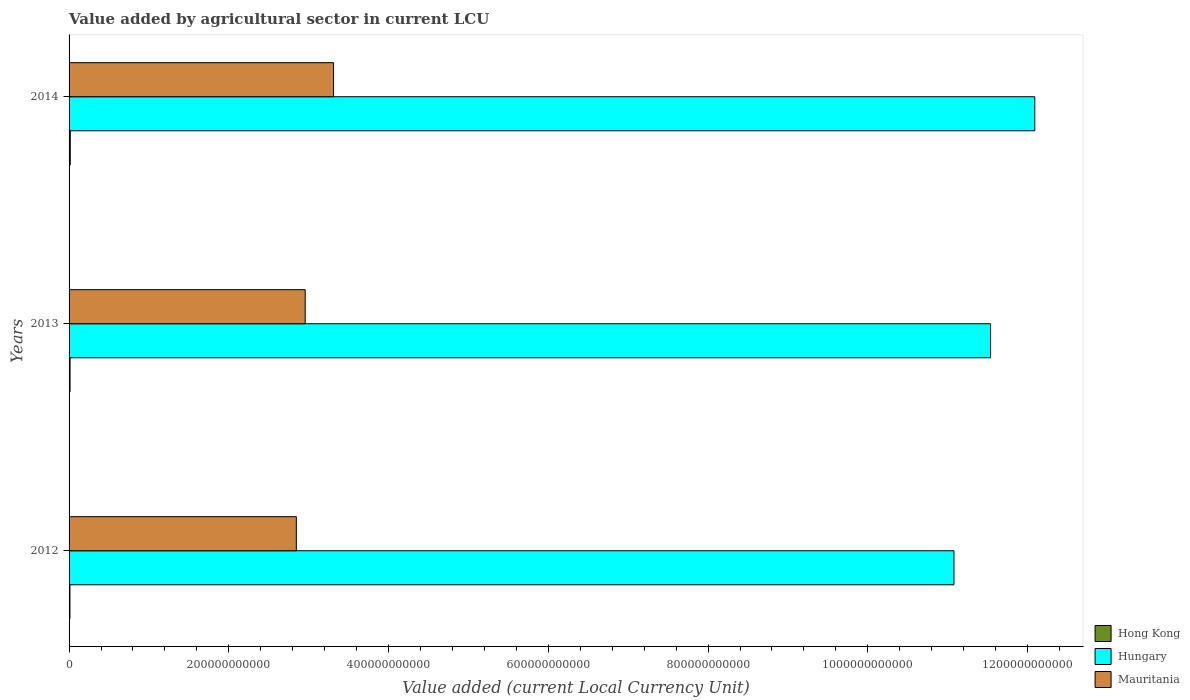How many different coloured bars are there?
Offer a terse response. 3. How many groups of bars are there?
Offer a very short reply. 3. Are the number of bars on each tick of the Y-axis equal?
Your response must be concise. Yes. How many bars are there on the 3rd tick from the top?
Make the answer very short. 3. What is the value added by agricultural sector in Mauritania in 2014?
Give a very brief answer. 3.31e+11. Across all years, what is the maximum value added by agricultural sector in Mauritania?
Provide a succinct answer. 3.31e+11. Across all years, what is the minimum value added by agricultural sector in Hungary?
Offer a very short reply. 1.11e+12. In which year was the value added by agricultural sector in Hungary maximum?
Provide a short and direct response. 2014. What is the total value added by agricultural sector in Mauritania in the graph?
Offer a terse response. 9.11e+11. What is the difference between the value added by agricultural sector in Hong Kong in 2012 and that in 2014?
Keep it short and to the point. -3.82e+08. What is the difference between the value added by agricultural sector in Hong Kong in 2013 and the value added by agricultural sector in Hungary in 2012?
Provide a succinct answer. -1.11e+12. What is the average value added by agricultural sector in Hong Kong per year?
Offer a very short reply. 1.28e+09. In the year 2012, what is the difference between the value added by agricultural sector in Mauritania and value added by agricultural sector in Hungary?
Your answer should be very brief. -8.23e+11. In how many years, is the value added by agricultural sector in Hong Kong greater than 720000000000 LCU?
Ensure brevity in your answer.  0. What is the ratio of the value added by agricultural sector in Hong Kong in 2012 to that in 2013?
Your response must be concise. 0.91. Is the value added by agricultural sector in Hong Kong in 2013 less than that in 2014?
Your answer should be very brief. Yes. Is the difference between the value added by agricultural sector in Mauritania in 2012 and 2014 greater than the difference between the value added by agricultural sector in Hungary in 2012 and 2014?
Provide a short and direct response. Yes. What is the difference between the highest and the second highest value added by agricultural sector in Mauritania?
Your response must be concise. 3.55e+1. What is the difference between the highest and the lowest value added by agricultural sector in Hong Kong?
Your answer should be compact. 3.82e+08. Is the sum of the value added by agricultural sector in Hungary in 2012 and 2013 greater than the maximum value added by agricultural sector in Mauritania across all years?
Keep it short and to the point. Yes. What does the 3rd bar from the top in 2013 represents?
Make the answer very short. Hong Kong. What does the 3rd bar from the bottom in 2013 represents?
Your answer should be very brief. Mauritania. Is it the case that in every year, the sum of the value added by agricultural sector in Hong Kong and value added by agricultural sector in Hungary is greater than the value added by agricultural sector in Mauritania?
Provide a succinct answer. Yes. Are all the bars in the graph horizontal?
Ensure brevity in your answer.  Yes. What is the difference between two consecutive major ticks on the X-axis?
Provide a short and direct response. 2.00e+11. Does the graph contain grids?
Ensure brevity in your answer.  No. How many legend labels are there?
Ensure brevity in your answer.  3. What is the title of the graph?
Keep it short and to the point. Value added by agricultural sector in current LCU. What is the label or title of the X-axis?
Keep it short and to the point. Value added (current Local Currency Unit). What is the Value added (current Local Currency Unit) in Hong Kong in 2012?
Your answer should be very brief. 1.11e+09. What is the Value added (current Local Currency Unit) in Hungary in 2012?
Provide a succinct answer. 1.11e+12. What is the Value added (current Local Currency Unit) in Mauritania in 2012?
Offer a very short reply. 2.85e+11. What is the Value added (current Local Currency Unit) of Hong Kong in 2013?
Your answer should be very brief. 1.22e+09. What is the Value added (current Local Currency Unit) in Hungary in 2013?
Provide a succinct answer. 1.15e+12. What is the Value added (current Local Currency Unit) of Mauritania in 2013?
Your answer should be very brief. 2.96e+11. What is the Value added (current Local Currency Unit) of Hong Kong in 2014?
Offer a terse response. 1.50e+09. What is the Value added (current Local Currency Unit) of Hungary in 2014?
Offer a terse response. 1.21e+12. What is the Value added (current Local Currency Unit) of Mauritania in 2014?
Your response must be concise. 3.31e+11. Across all years, what is the maximum Value added (current Local Currency Unit) in Hong Kong?
Your response must be concise. 1.50e+09. Across all years, what is the maximum Value added (current Local Currency Unit) of Hungary?
Your answer should be compact. 1.21e+12. Across all years, what is the maximum Value added (current Local Currency Unit) of Mauritania?
Make the answer very short. 3.31e+11. Across all years, what is the minimum Value added (current Local Currency Unit) in Hong Kong?
Your answer should be very brief. 1.11e+09. Across all years, what is the minimum Value added (current Local Currency Unit) of Hungary?
Provide a succinct answer. 1.11e+12. Across all years, what is the minimum Value added (current Local Currency Unit) of Mauritania?
Offer a very short reply. 2.85e+11. What is the total Value added (current Local Currency Unit) of Hong Kong in the graph?
Your answer should be very brief. 3.84e+09. What is the total Value added (current Local Currency Unit) of Hungary in the graph?
Make the answer very short. 3.47e+12. What is the total Value added (current Local Currency Unit) in Mauritania in the graph?
Keep it short and to the point. 9.11e+11. What is the difference between the Value added (current Local Currency Unit) in Hong Kong in 2012 and that in 2013?
Ensure brevity in your answer.  -1.11e+08. What is the difference between the Value added (current Local Currency Unit) in Hungary in 2012 and that in 2013?
Ensure brevity in your answer.  -4.59e+1. What is the difference between the Value added (current Local Currency Unit) in Mauritania in 2012 and that in 2013?
Provide a succinct answer. -1.11e+1. What is the difference between the Value added (current Local Currency Unit) of Hong Kong in 2012 and that in 2014?
Provide a short and direct response. -3.82e+08. What is the difference between the Value added (current Local Currency Unit) in Hungary in 2012 and that in 2014?
Make the answer very short. -1.01e+11. What is the difference between the Value added (current Local Currency Unit) of Mauritania in 2012 and that in 2014?
Give a very brief answer. -4.66e+1. What is the difference between the Value added (current Local Currency Unit) in Hong Kong in 2013 and that in 2014?
Ensure brevity in your answer.  -2.71e+08. What is the difference between the Value added (current Local Currency Unit) in Hungary in 2013 and that in 2014?
Your answer should be compact. -5.53e+1. What is the difference between the Value added (current Local Currency Unit) of Mauritania in 2013 and that in 2014?
Provide a short and direct response. -3.55e+1. What is the difference between the Value added (current Local Currency Unit) of Hong Kong in 2012 and the Value added (current Local Currency Unit) of Hungary in 2013?
Your answer should be compact. -1.15e+12. What is the difference between the Value added (current Local Currency Unit) of Hong Kong in 2012 and the Value added (current Local Currency Unit) of Mauritania in 2013?
Offer a terse response. -2.95e+11. What is the difference between the Value added (current Local Currency Unit) in Hungary in 2012 and the Value added (current Local Currency Unit) in Mauritania in 2013?
Provide a short and direct response. 8.12e+11. What is the difference between the Value added (current Local Currency Unit) of Hong Kong in 2012 and the Value added (current Local Currency Unit) of Hungary in 2014?
Make the answer very short. -1.21e+12. What is the difference between the Value added (current Local Currency Unit) in Hong Kong in 2012 and the Value added (current Local Currency Unit) in Mauritania in 2014?
Offer a terse response. -3.30e+11. What is the difference between the Value added (current Local Currency Unit) of Hungary in 2012 and the Value added (current Local Currency Unit) of Mauritania in 2014?
Offer a terse response. 7.77e+11. What is the difference between the Value added (current Local Currency Unit) of Hong Kong in 2013 and the Value added (current Local Currency Unit) of Hungary in 2014?
Make the answer very short. -1.21e+12. What is the difference between the Value added (current Local Currency Unit) of Hong Kong in 2013 and the Value added (current Local Currency Unit) of Mauritania in 2014?
Your answer should be compact. -3.30e+11. What is the difference between the Value added (current Local Currency Unit) of Hungary in 2013 and the Value added (current Local Currency Unit) of Mauritania in 2014?
Offer a very short reply. 8.23e+11. What is the average Value added (current Local Currency Unit) in Hong Kong per year?
Keep it short and to the point. 1.28e+09. What is the average Value added (current Local Currency Unit) in Hungary per year?
Provide a succinct answer. 1.16e+12. What is the average Value added (current Local Currency Unit) in Mauritania per year?
Give a very brief answer. 3.04e+11. In the year 2012, what is the difference between the Value added (current Local Currency Unit) of Hong Kong and Value added (current Local Currency Unit) of Hungary?
Offer a terse response. -1.11e+12. In the year 2012, what is the difference between the Value added (current Local Currency Unit) of Hong Kong and Value added (current Local Currency Unit) of Mauritania?
Your answer should be compact. -2.83e+11. In the year 2012, what is the difference between the Value added (current Local Currency Unit) of Hungary and Value added (current Local Currency Unit) of Mauritania?
Provide a succinct answer. 8.23e+11. In the year 2013, what is the difference between the Value added (current Local Currency Unit) of Hong Kong and Value added (current Local Currency Unit) of Hungary?
Keep it short and to the point. -1.15e+12. In the year 2013, what is the difference between the Value added (current Local Currency Unit) in Hong Kong and Value added (current Local Currency Unit) in Mauritania?
Your response must be concise. -2.94e+11. In the year 2013, what is the difference between the Value added (current Local Currency Unit) in Hungary and Value added (current Local Currency Unit) in Mauritania?
Provide a short and direct response. 8.58e+11. In the year 2014, what is the difference between the Value added (current Local Currency Unit) of Hong Kong and Value added (current Local Currency Unit) of Hungary?
Keep it short and to the point. -1.21e+12. In the year 2014, what is the difference between the Value added (current Local Currency Unit) in Hong Kong and Value added (current Local Currency Unit) in Mauritania?
Offer a very short reply. -3.30e+11. In the year 2014, what is the difference between the Value added (current Local Currency Unit) in Hungary and Value added (current Local Currency Unit) in Mauritania?
Offer a terse response. 8.78e+11. What is the ratio of the Value added (current Local Currency Unit) in Hong Kong in 2012 to that in 2013?
Your answer should be very brief. 0.91. What is the ratio of the Value added (current Local Currency Unit) in Hungary in 2012 to that in 2013?
Your response must be concise. 0.96. What is the ratio of the Value added (current Local Currency Unit) in Mauritania in 2012 to that in 2013?
Offer a terse response. 0.96. What is the ratio of the Value added (current Local Currency Unit) of Hong Kong in 2012 to that in 2014?
Provide a short and direct response. 0.74. What is the ratio of the Value added (current Local Currency Unit) in Hungary in 2012 to that in 2014?
Make the answer very short. 0.92. What is the ratio of the Value added (current Local Currency Unit) in Mauritania in 2012 to that in 2014?
Provide a short and direct response. 0.86. What is the ratio of the Value added (current Local Currency Unit) of Hong Kong in 2013 to that in 2014?
Ensure brevity in your answer.  0.82. What is the ratio of the Value added (current Local Currency Unit) of Hungary in 2013 to that in 2014?
Keep it short and to the point. 0.95. What is the ratio of the Value added (current Local Currency Unit) in Mauritania in 2013 to that in 2014?
Your answer should be compact. 0.89. What is the difference between the highest and the second highest Value added (current Local Currency Unit) in Hong Kong?
Your answer should be compact. 2.71e+08. What is the difference between the highest and the second highest Value added (current Local Currency Unit) of Hungary?
Your response must be concise. 5.53e+1. What is the difference between the highest and the second highest Value added (current Local Currency Unit) of Mauritania?
Keep it short and to the point. 3.55e+1. What is the difference between the highest and the lowest Value added (current Local Currency Unit) in Hong Kong?
Give a very brief answer. 3.82e+08. What is the difference between the highest and the lowest Value added (current Local Currency Unit) in Hungary?
Your answer should be compact. 1.01e+11. What is the difference between the highest and the lowest Value added (current Local Currency Unit) of Mauritania?
Your response must be concise. 4.66e+1. 